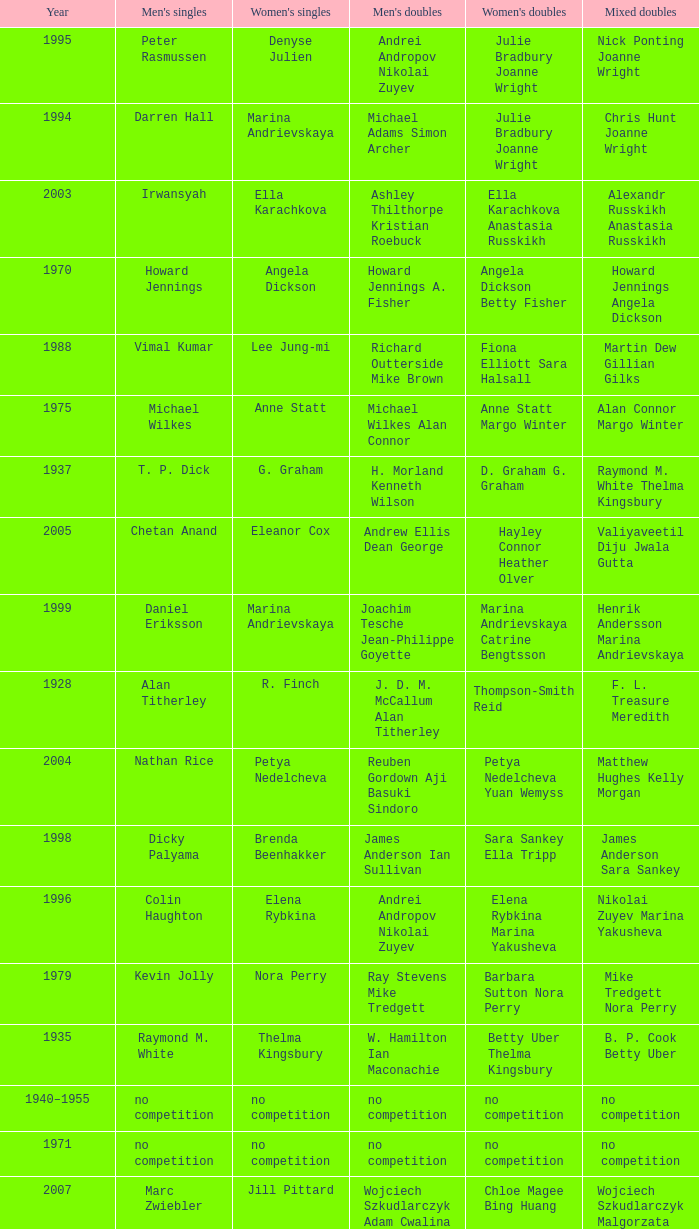Who won the Men's singles in the year that Ian Maconachie Marian Horsley won the Mixed doubles? Raymond M. White. Parse the table in full. {'header': ['Year', "Men's singles", "Women's singles", "Men's doubles", "Women's doubles", 'Mixed doubles'], 'rows': [['1995', 'Peter Rasmussen', 'Denyse Julien', 'Andrei Andropov Nikolai Zuyev', 'Julie Bradbury Joanne Wright', 'Nick Ponting Joanne Wright'], ['1994', 'Darren Hall', 'Marina Andrievskaya', 'Michael Adams Simon Archer', 'Julie Bradbury Joanne Wright', 'Chris Hunt Joanne Wright'], ['2003', 'Irwansyah', 'Ella Karachkova', 'Ashley Thilthorpe Kristian Roebuck', 'Ella Karachkova Anastasia Russkikh', 'Alexandr Russkikh Anastasia Russkikh'], ['1970', 'Howard Jennings', 'Angela Dickson', 'Howard Jennings A. Fisher', 'Angela Dickson Betty Fisher', 'Howard Jennings Angela Dickson'], ['1988', 'Vimal Kumar', 'Lee Jung-mi', 'Richard Outterside Mike Brown', 'Fiona Elliott Sara Halsall', 'Martin Dew Gillian Gilks'], ['1975', 'Michael Wilkes', 'Anne Statt', 'Michael Wilkes Alan Connor', 'Anne Statt Margo Winter', 'Alan Connor Margo Winter'], ['1937', 'T. P. Dick', 'G. Graham', 'H. Morland Kenneth Wilson', 'D. Graham G. Graham', 'Raymond M. White Thelma Kingsbury'], ['2005', 'Chetan Anand', 'Eleanor Cox', 'Andrew Ellis Dean George', 'Hayley Connor Heather Olver', 'Valiyaveetil Diju Jwala Gutta'], ['1999', 'Daniel Eriksson', 'Marina Andrievskaya', 'Joachim Tesche Jean-Philippe Goyette', 'Marina Andrievskaya Catrine Bengtsson', 'Henrik Andersson Marina Andrievskaya'], ['1928', 'Alan Titherley', 'R. Finch', 'J. D. M. McCallum Alan Titherley', 'Thompson-Smith Reid', 'F. L. Treasure Meredith'], ['2004', 'Nathan Rice', 'Petya Nedelcheva', 'Reuben Gordown Aji Basuki Sindoro', 'Petya Nedelcheva Yuan Wemyss', 'Matthew Hughes Kelly Morgan'], ['1998', 'Dicky Palyama', 'Brenda Beenhakker', 'James Anderson Ian Sullivan', 'Sara Sankey Ella Tripp', 'James Anderson Sara Sankey'], ['1996', 'Colin Haughton', 'Elena Rybkina', 'Andrei Andropov Nikolai Zuyev', 'Elena Rybkina Marina Yakusheva', 'Nikolai Zuyev Marina Yakusheva'], ['1979', 'Kevin Jolly', 'Nora Perry', 'Ray Stevens Mike Tredgett', 'Barbara Sutton Nora Perry', 'Mike Tredgett Nora Perry'], ['1935', 'Raymond M. White', 'Thelma Kingsbury', 'W. Hamilton Ian Maconachie', 'Betty Uber Thelma Kingsbury', 'B. P. Cook Betty Uber'], ['1940–1955', 'no competition', 'no competition', 'no competition', 'no competition', 'no competition'], ['1971', 'no competition', 'no competition', 'no competition', 'no competition', 'no competition'], ['2007', 'Marc Zwiebler', 'Jill Pittard', 'Wojciech Szkudlarczyk Adam Cwalina', 'Chloe Magee Bing Huang', 'Wojciech Szkudlarczyk Malgorzata Kurdelska'], ['2008', 'Brice Leverdez', 'Kati Tolmoff', 'Andrew Bowman Martyn Lewis', 'Mariana Agathangelou Jillie Cooper', 'Watson Briggs Jillie Cooper'], ['1967', 'Roger Mills', 'Mary Thompson', 'Roger Mills Robert McCoig', 'M. Withers Betty Fisher', 'Robert McCoig Coig'], ['2009', 'Kristian Nielsen', 'Tatjana Bibik', 'Vitaliy Durkin Alexandr Nikolaenko', 'Valeria Sorokina Nina Vislova', 'Vitaliy Durkin Nina Vislova'], ['2000', 'Richard Vaughan', 'Marina Yakusheva', 'Joachim Andersson Peter Axelsson', 'Irina Ruslyakova Marina Yakusheva', 'Peter Jeffrey Joanne Davies'], ['1982', 'Steve Baddeley', 'Karen Bridge', 'David Eddy Eddy Sutton', 'Karen Chapman Sally Podger', 'Billy Gilliland Karen Chapman'], ['1957', 'Oon Chong Teik', 'Maggie McIntosh', 'Kenneth Derrick A. R. V. Dolman', 'J. A. Russell Maggie McIntosh', 'Kenneth Derrick B. Maxwell'], ['1933', 'W. Hamilton', 'Alice Woodroffe', 'Donald Hume Raymond M. White', 'L. W. Myers Alice Woodroffe', 'T. P. Dick Hazel Hogarth'], ['1980', 'Thomas Kihlström', 'Jane Webster', 'Thomas Kihlström Bengt Fröman', 'Jane Webster Karen Puttick', 'Billy Gilliland Karen Puttick'], ['1987', 'Darren Hall', 'Fiona Elliott', 'Martin Dew Darren Hall', 'Karen Beckman Sara Halsall', 'Martin Dew Gillian Gilks'], ['1938', 'Raymond M. White', 'Daphne Young', 'T. P. Dick H. E. Baldwin', 'L. W. Myers Dorothy Colpoys', 'Thomas Boyle Olive Wilson'], ['1986', 'Darren Hall', 'Fiona Elliott', 'Martin Dew Dipak Tailor', 'Karen Beckman Sara Halsall', 'Jesper Knudsen Nettie Nielsen'], ['1968', 'Roger Mills', 'Julie Charles', 'Roger Mills J. G. Pearson', 'Julie Charles Angela Dickson', 'Roger Mills Julie Charles'], ['1932', 'W. Hamilton', 'Thelma Kingsbury', 'Artur Hamilton W. Hamilton', 'Hazel Hogarth Thelma Kingsbury', 'Ralph Nichols N. Coop'], ['1929', 'T. P. Dick', 'Margaret Tragett', 'F. J. Treasure F. B. Malthouse', 'Marian Horsley L. W. Myers', 'T. P. Dick Hazel Hogarth'], ['1936', 'Raymond M. White', 'Thelma Kingsbury', 'Raymond M. White Ian Maconachie', 'Betty Uber Thelma Kingsbury', 'Ian Maconachie Marian Horsley'], ['2012', 'Chou Tien-chen', 'Chiang Mei-hui', 'Marcus Ellis Paul Van Rietvelde', 'Gabrielle White Lauren Smith', 'Marcus Ellis Gabrielle White'], ['1989', 'Darren Hall', 'Bang Soo-hyun', 'Nick Ponting Dave Wright', 'Karen Beckman Sara Sankey', 'Mike Brown Jillian Wallwork'], ['1981', 'Ray Stevens', 'Gillian Gilks', 'Ray Stevens Mike Tredgett', 'Gillian Gilks Paula Kilvington', 'Mike Tredgett Nora Perry'], ['1990', 'Mathew Smith', 'Joanne Muggeridge', 'Nick Ponting Dave Wright', 'Karen Chapman Sara Sankey', 'Dave Wright Claire Palmer'], ['1973', 'John Gardner', 'Barbara Beckett', 'John McCloy Peter Moore', 'Anne Forrest Kathleen Whiting', 'Clifford McIlwaine Barbara Beckett'], ['1939', 'Tage Madsen', 'Betty Uber', 'Thomas Boyle James Rankin', 'Betty Uber Diana Doveton', 'Thomas Boyle Olive Wilson'], ['1931', 'T. P. Dick', 'Dorothy Colpoys', 'T. P. Dick W. Basil Jones', 'Marian Horsley L. W. Myers', 'T. P. Dick Hazel Hogarth'], ['1977', 'David Eddy', 'Paula Kilvington', 'David Eddy Eddy Sutton', 'Anne Statt Jane Webster', 'David Eddy Barbara Giles'], ['1958', 'Oon Chong Jin', "Mary O'Sullivan", 'Kenneth Derrick A. R. V. Dolman', 'June Timperley Patricia Dolan', 'Oon Chong Jin June Timperley'], ['2010', 'Pablo Abián', 'Anita Raj Kaur', 'Peter Käsbauer Josche Zurwonne', 'Joanne Quay Swee Ling Anita Raj Kaur', 'Peter Käsbauer Johanna Goliszewski'], ['2011', 'Niluka Karunaratne', 'Nicole Schaller', 'Chris Coles Matthew Nottingham', 'Ng Hui Ern Ng Hui Lin', 'Martin Campbell Ng Hui Lin'], ['1956', 'James P. Doyle', 'H. B. Mercer', 'Desmond Lacey James P. Doyle', 'H. B. Mercer R. Smyth', 'Kenneth Carlisle R. Smyth'], ['1959', 'Hugh Findlay', 'Heather Ward', 'Tony Jordan Hugh Findlay', 'Heather Ward P. E. Broad', 'Hugh Findlay Heather Ward'], ['2006', 'Irwansyah', 'Huang Chia-chi', 'Matthew Hughes Martyn Lewis', 'Natalie Munt Mariana Agathangelou', 'Kristian Roebuck Natalie Munt'], ['1992', 'Wei Yan', 'Fiona Smith', 'Michael Adams Chris Rees', 'Denyse Julien Doris Piché', 'Andy Goode Joanne Wright'], ['1930', 'Donald Hume', 'Dorothy Colpoys', 'Donald Hume Ralph Nichols', 'Marian Horsley L. W. Myers', 'T. P. Dick Hazel Hogarth'], ['1978', 'Mike Tredgett', 'Gillian Gilks', 'David Eddy Eddy Sutton', 'Barbara Sutton Marjan Ridder', 'Elliot Stuart Gillian Gilks'], ['1983', 'Steve Butler', 'Sally Podger', 'Mike Tredgett Dipak Tailor', 'Nora Perry Jane Webster', 'Dipak Tailor Nora Perry'], ['1985', 'Morten Frost', 'Charlotte Hattens', 'Billy Gilliland Dan Travers', 'Gillian Gilks Helen Troke', 'Martin Dew Gillian Gilks'], ['1993', 'Anders Nielsen', 'Sue Louis Lane', 'Nick Ponting Dave Wright', 'Julie Bradbury Sara Sankey', 'Nick Ponting Joanne Wright'], ['1974', 'Michael Wilkes', 'Barbara Beckett', 'Michael Wilkes Alan Connor', 'Barbara Beckett Sue Alfieri', 'Michael Wilkes Anne Forrest'], ['1960–1966', 'no competition', 'no competition', 'no competition', 'no competition', 'no competition'], ['2002', 'Irwansyah', 'Karina de Wit', 'Nikolai Zuyev Stanislav Pukhov', 'Ella Tripp Joanne Wright', 'Nikolai Zuyev Marina Yakusheva'], ['2001', 'Irwansyah', 'Brenda Beenhakker', 'Vincent Laigle Svetoslav Stoyanov', 'Sara Sankey Ella Tripp', 'Nikolai Zuyev Marina Yakusheva'], ['1991', 'Vimal Kumar', 'Denyse Julien', 'Nick Ponting Dave Wright', 'Cheryl Johnson Julie Bradbury', 'Nick Ponting Joanne Wright'], ['1972', 'Mike Tredgett', 'Betty Fisher', 'P. Smith William Kidd', 'Angela Dickson Betty Fisher', 'Mike Tredgett Kathleen Whiting'], ['1934', 'W. Hamilton', 'Betty Uber', 'Donald Hume Raymond M. White', 'Betty Uber Thelma Kingsbury', 'Donald Hume Betty Uber'], ['1969', 'Howard Jennings', 'Angela Dickson', 'Mike Tredgett A. Finch', 'J. Masters R. Gerrish', 'Howard Jennings Angela Dickson'], ['1984', 'Steve Butler', 'Karen Beckman', 'Mike Tredgett Martin Dew', 'Helen Troke Karen Chapman', 'Mike Tredgett Karen Chapman'], ['1976', 'Kevin Jolly', 'Pat Davies', 'Tim Stokes Kevin Jolly', 'Angela Dickson Sue Brimble', 'Howard Jennings Angela Dickson'], ['1997', 'Chris Bruil', 'Kelly Morgan', 'Ian Pearson James Anderson', 'Nicole van Hooren Brenda Conijn', 'Quinten van Dalm Nicole van Hooren']]} 